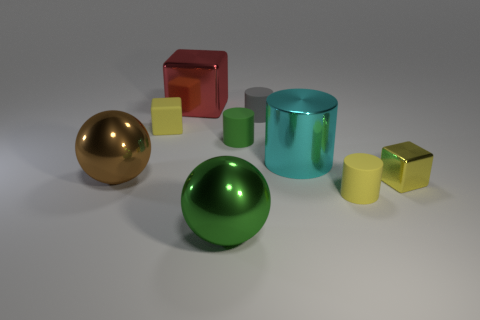Subtract 1 cylinders. How many cylinders are left? 3 Subtract all cyan spheres. Subtract all cyan cylinders. How many spheres are left? 2 Subtract all balls. How many objects are left? 7 Subtract all tiny green matte objects. Subtract all big red metal things. How many objects are left? 7 Add 3 small yellow things. How many small yellow things are left? 6 Add 2 large red metallic objects. How many large red metallic objects exist? 3 Subtract 0 green cubes. How many objects are left? 9 